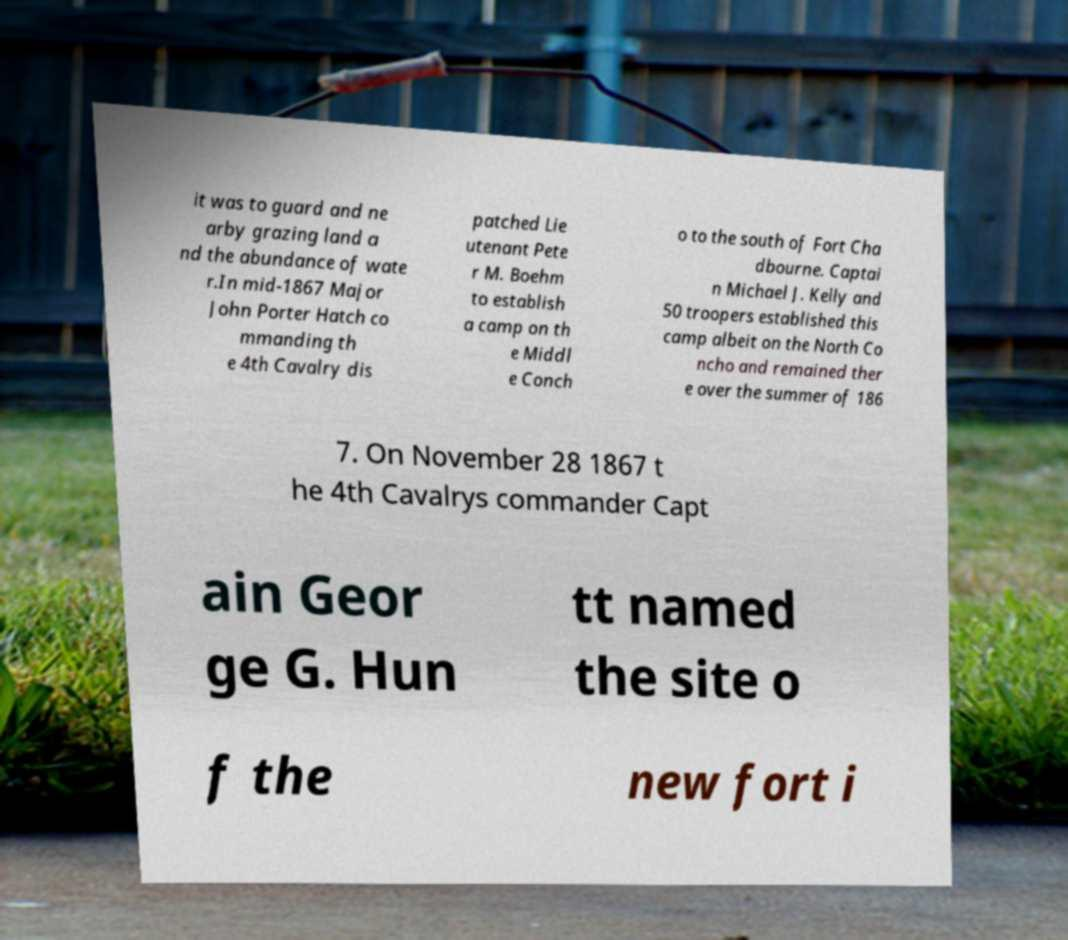I need the written content from this picture converted into text. Can you do that? it was to guard and ne arby grazing land a nd the abundance of wate r.In mid-1867 Major John Porter Hatch co mmanding th e 4th Cavalry dis patched Lie utenant Pete r M. Boehm to establish a camp on th e Middl e Conch o to the south of Fort Cha dbourne. Captai n Michael J. Kelly and 50 troopers established this camp albeit on the North Co ncho and remained ther e over the summer of 186 7. On November 28 1867 t he 4th Cavalrys commander Capt ain Geor ge G. Hun tt named the site o f the new fort i 